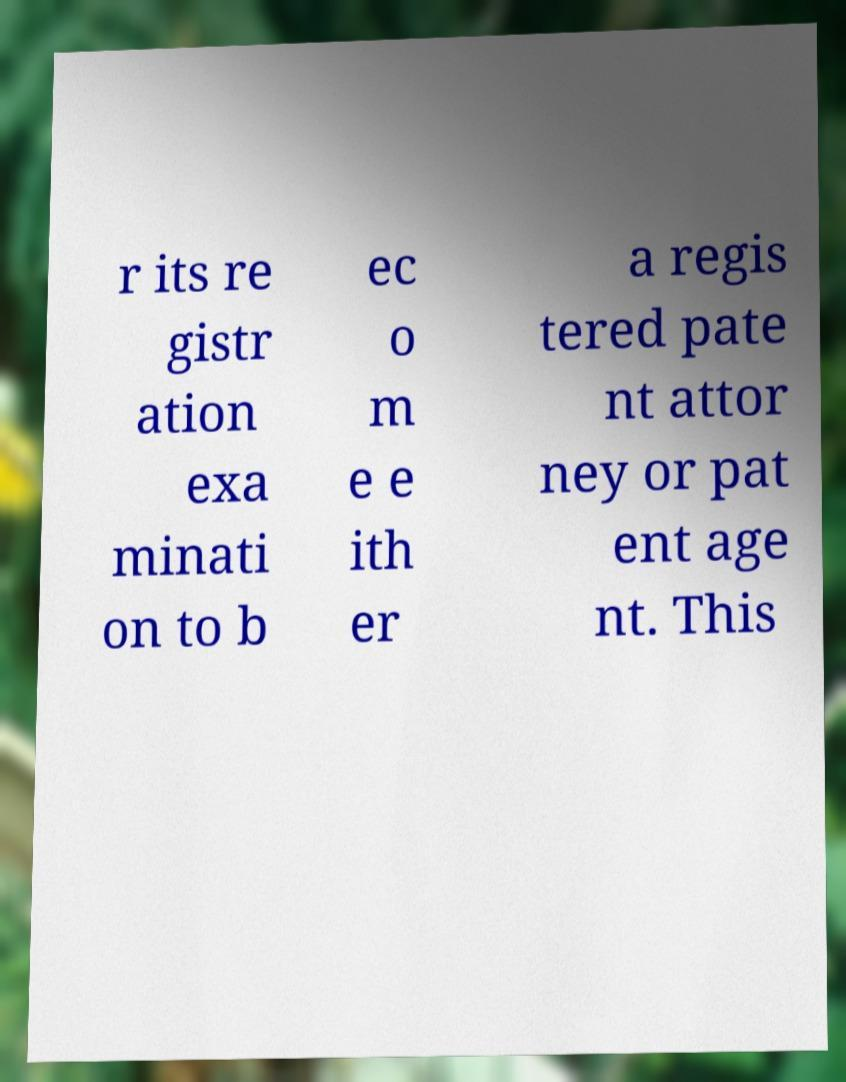Could you extract and type out the text from this image? r its re gistr ation exa minati on to b ec o m e e ith er a regis tered pate nt attor ney or pat ent age nt. This 